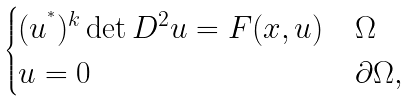Convert formula to latex. <formula><loc_0><loc_0><loc_500><loc_500>\begin{cases} ( u ^ { ^ { * } } ) ^ { k } \det D ^ { 2 } u = F ( x , u ) & \Omega \\ u = 0 & \partial \Omega , \end{cases}</formula> 